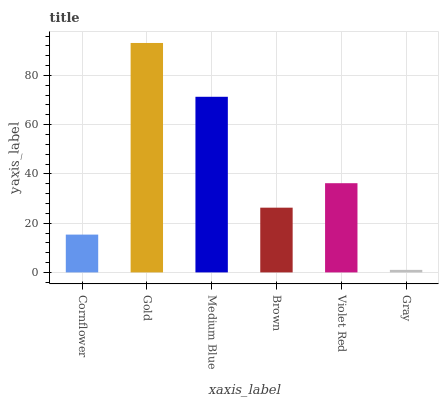Is Gray the minimum?
Answer yes or no. Yes. Is Gold the maximum?
Answer yes or no. Yes. Is Medium Blue the minimum?
Answer yes or no. No. Is Medium Blue the maximum?
Answer yes or no. No. Is Gold greater than Medium Blue?
Answer yes or no. Yes. Is Medium Blue less than Gold?
Answer yes or no. Yes. Is Medium Blue greater than Gold?
Answer yes or no. No. Is Gold less than Medium Blue?
Answer yes or no. No. Is Violet Red the high median?
Answer yes or no. Yes. Is Brown the low median?
Answer yes or no. Yes. Is Gold the high median?
Answer yes or no. No. Is Medium Blue the low median?
Answer yes or no. No. 